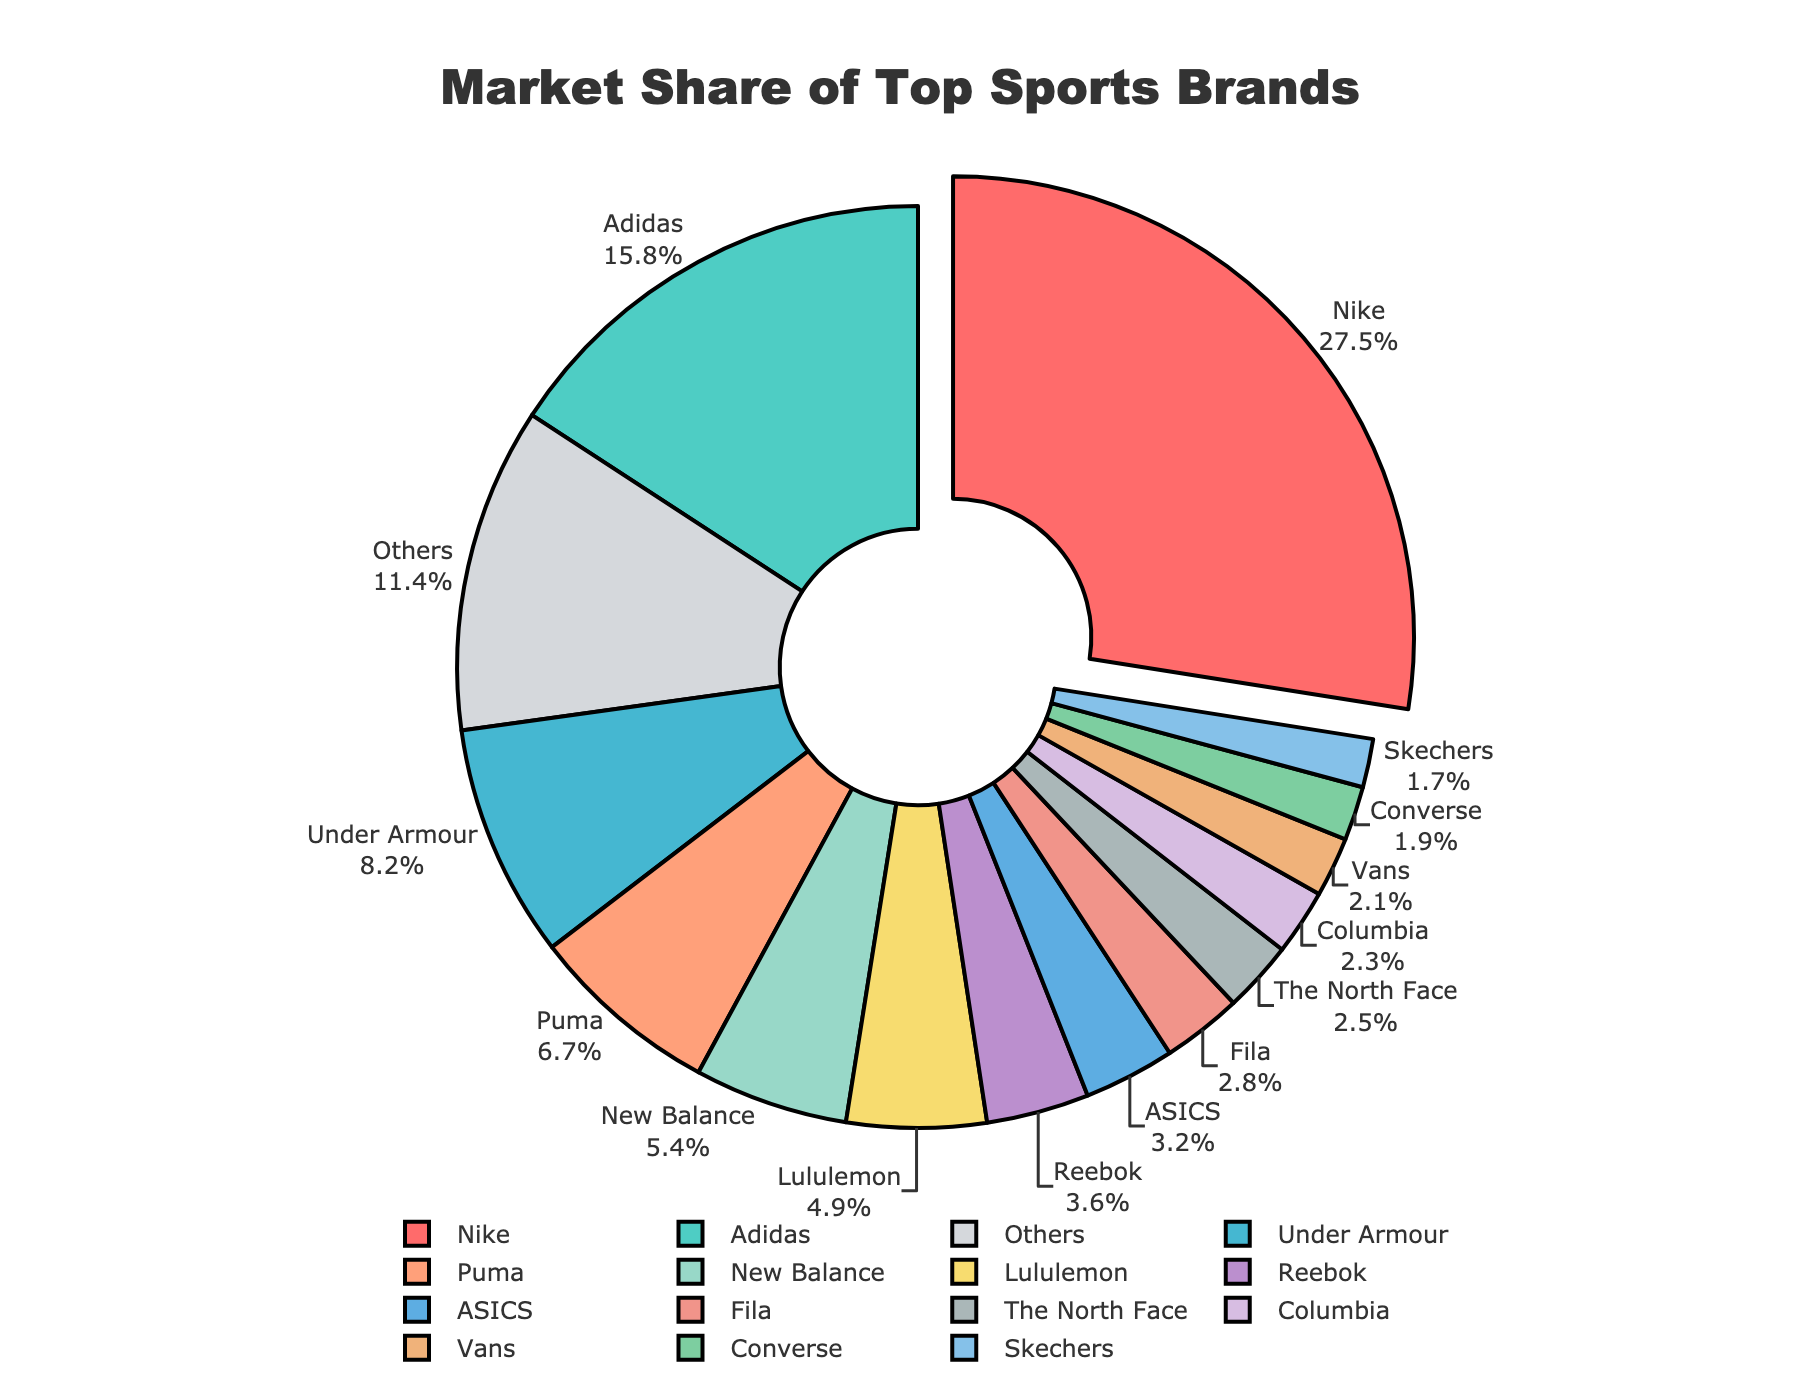Which brand has the highest market share? The brand with the highest market share is easily identifiable by the largest segment in the pie chart. Nike has the largest segment.
Answer: Nike Which two brands together account for over 40% of the market share? By looking at the pie chart and summing the market shares, Nike has 27.5% and Adidas has 15.8%. Together, they account for 27.5% + 15.8% = 43.3%, which is over 40%.
Answer: Nike and Adidas How much larger is Nike's market share compared to Under Armour's? Nike has a market share of 27.5%, and Under Armour has 8.2%. The difference is 27.5% - 8.2% = 19.3%.
Answer: 19.3% What is the combined market share of brands that each have less than 5%? Adding the market shares of brands with less than 5%: New Balance 5.4% (excluded), Lululemon 4.9%, Reebok 3.6%, ASICS 3.2%, Fila 2.8%, The North Face 2.5%, Columbia 2.3%, Vans 2.1%, Converse 1.9%, Skechers 1.7%, Others 11.4%. The combined market share is 4.9% + 3.6% + 3.2% + 2.8% + 2.5% + 2.3% + 2.1% + 1.9% + 1.7% + 11.4% = 38.4%.
Answer: 38.4% Which brands have a market share exactly between 5% and 10%? By referring to the pie chart, Under Armour has 8.2% and Puma has 6.7%. These two brands fall in the 5-10% range.
Answer: Under Armour and Puma Is Adidas's market share more than twice that of Puma's? Adidas has a market share of 15.8% and Puma has 6.7%. Twice Puma's share is 6.7% * 2 = 13.4%. Since 15.8% is greater than 13.4%, Adidas's market share is more than twice that of Puma's.
Answer: Yes Which brand has the smallest market share? By observing the pie chart, Converse has the smallest segment with a market share of 1.9%.
Answer: Converse What percentage of the market do the top three brands control? Adding the market shares of Nike (27.5%), Adidas (15.8%), and Under Armour (8.2%): 27.5% + 15.8% + 8.2% = 51.5%.
Answer: 51.5% Describe the color of the segment representing Puma's market share. The segment representing Puma stands out with a visible color close to peach or light salmon.
Answer: Light salmon 